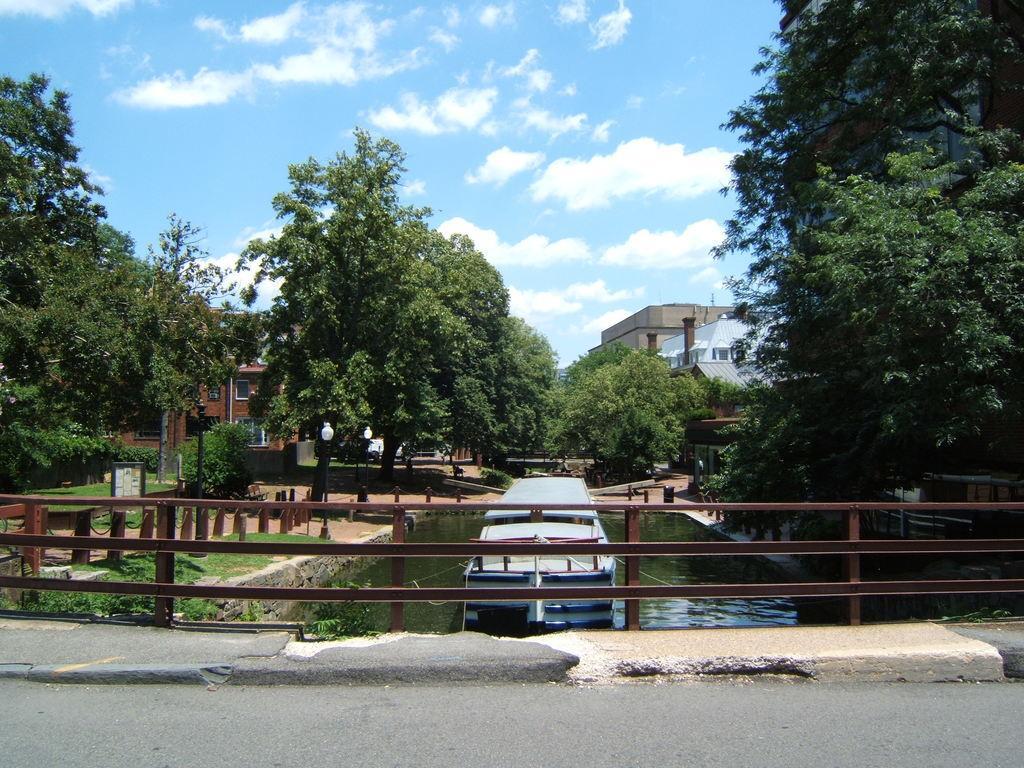Can you describe this image briefly? This picture is clicked outside. In the foreground we can see the metal fence and an object in the water body and we can see the green grass, trees and plants. In the background we can see the sky and the buildings and some other objects. 